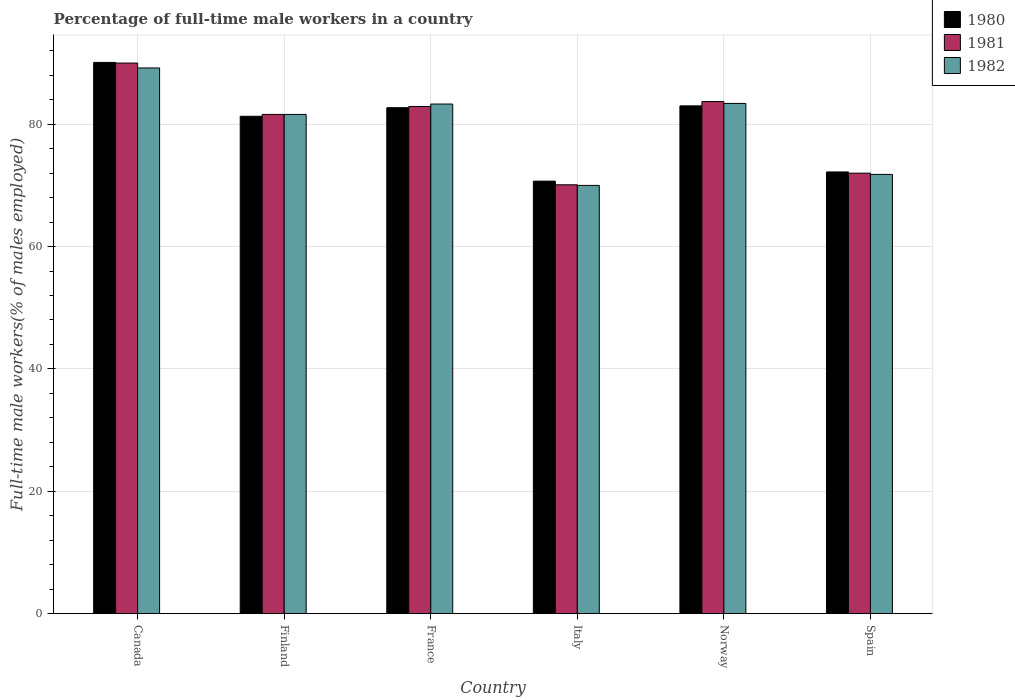How many different coloured bars are there?
Ensure brevity in your answer.  3. How many groups of bars are there?
Keep it short and to the point. 6. Are the number of bars on each tick of the X-axis equal?
Provide a succinct answer. Yes. How many bars are there on the 2nd tick from the left?
Make the answer very short. 3. How many bars are there on the 1st tick from the right?
Your response must be concise. 3. In how many cases, is the number of bars for a given country not equal to the number of legend labels?
Make the answer very short. 0. What is the percentage of full-time male workers in 1982 in Finland?
Your answer should be very brief. 81.6. Across all countries, what is the maximum percentage of full-time male workers in 1980?
Your response must be concise. 90.1. In which country was the percentage of full-time male workers in 1981 maximum?
Your answer should be very brief. Canada. In which country was the percentage of full-time male workers in 1981 minimum?
Keep it short and to the point. Italy. What is the total percentage of full-time male workers in 1982 in the graph?
Offer a terse response. 479.3. What is the difference between the percentage of full-time male workers in 1981 in France and that in Spain?
Your answer should be very brief. 10.9. What is the difference between the percentage of full-time male workers in 1981 in France and the percentage of full-time male workers in 1980 in Italy?
Your response must be concise. 12.2. What is the average percentage of full-time male workers in 1982 per country?
Make the answer very short. 79.88. What is the difference between the percentage of full-time male workers of/in 1980 and percentage of full-time male workers of/in 1981 in Canada?
Ensure brevity in your answer.  0.1. What is the ratio of the percentage of full-time male workers in 1980 in Finland to that in Italy?
Give a very brief answer. 1.15. What is the difference between the highest and the second highest percentage of full-time male workers in 1982?
Offer a very short reply. 5.9. What is the difference between the highest and the lowest percentage of full-time male workers in 1980?
Make the answer very short. 19.4. In how many countries, is the percentage of full-time male workers in 1980 greater than the average percentage of full-time male workers in 1980 taken over all countries?
Provide a short and direct response. 4. Is the sum of the percentage of full-time male workers in 1982 in Canada and Italy greater than the maximum percentage of full-time male workers in 1980 across all countries?
Ensure brevity in your answer.  Yes. What does the 3rd bar from the left in Italy represents?
Your response must be concise. 1982. Is it the case that in every country, the sum of the percentage of full-time male workers in 1981 and percentage of full-time male workers in 1980 is greater than the percentage of full-time male workers in 1982?
Ensure brevity in your answer.  Yes. How many bars are there?
Your response must be concise. 18. Are all the bars in the graph horizontal?
Your answer should be compact. No. How many countries are there in the graph?
Your answer should be very brief. 6. What is the difference between two consecutive major ticks on the Y-axis?
Provide a short and direct response. 20. Are the values on the major ticks of Y-axis written in scientific E-notation?
Provide a succinct answer. No. Where does the legend appear in the graph?
Make the answer very short. Top right. How many legend labels are there?
Ensure brevity in your answer.  3. How are the legend labels stacked?
Keep it short and to the point. Vertical. What is the title of the graph?
Keep it short and to the point. Percentage of full-time male workers in a country. What is the label or title of the Y-axis?
Give a very brief answer. Full-time male workers(% of males employed). What is the Full-time male workers(% of males employed) of 1980 in Canada?
Offer a terse response. 90.1. What is the Full-time male workers(% of males employed) in 1981 in Canada?
Offer a terse response. 90. What is the Full-time male workers(% of males employed) of 1982 in Canada?
Make the answer very short. 89.2. What is the Full-time male workers(% of males employed) in 1980 in Finland?
Give a very brief answer. 81.3. What is the Full-time male workers(% of males employed) of 1981 in Finland?
Offer a very short reply. 81.6. What is the Full-time male workers(% of males employed) of 1982 in Finland?
Your answer should be very brief. 81.6. What is the Full-time male workers(% of males employed) of 1980 in France?
Make the answer very short. 82.7. What is the Full-time male workers(% of males employed) of 1981 in France?
Your answer should be compact. 82.9. What is the Full-time male workers(% of males employed) in 1982 in France?
Your answer should be compact. 83.3. What is the Full-time male workers(% of males employed) of 1980 in Italy?
Provide a short and direct response. 70.7. What is the Full-time male workers(% of males employed) of 1981 in Italy?
Make the answer very short. 70.1. What is the Full-time male workers(% of males employed) in 1982 in Italy?
Ensure brevity in your answer.  70. What is the Full-time male workers(% of males employed) in 1981 in Norway?
Keep it short and to the point. 83.7. What is the Full-time male workers(% of males employed) in 1982 in Norway?
Keep it short and to the point. 83.4. What is the Full-time male workers(% of males employed) in 1980 in Spain?
Ensure brevity in your answer.  72.2. What is the Full-time male workers(% of males employed) of 1982 in Spain?
Your answer should be compact. 71.8. Across all countries, what is the maximum Full-time male workers(% of males employed) of 1980?
Provide a short and direct response. 90.1. Across all countries, what is the maximum Full-time male workers(% of males employed) in 1982?
Ensure brevity in your answer.  89.2. Across all countries, what is the minimum Full-time male workers(% of males employed) of 1980?
Offer a terse response. 70.7. Across all countries, what is the minimum Full-time male workers(% of males employed) of 1981?
Keep it short and to the point. 70.1. What is the total Full-time male workers(% of males employed) of 1980 in the graph?
Offer a terse response. 480. What is the total Full-time male workers(% of males employed) of 1981 in the graph?
Your answer should be very brief. 480.3. What is the total Full-time male workers(% of males employed) of 1982 in the graph?
Provide a short and direct response. 479.3. What is the difference between the Full-time male workers(% of males employed) in 1982 in Canada and that in Finland?
Keep it short and to the point. 7.6. What is the difference between the Full-time male workers(% of males employed) in 1980 in Canada and that in France?
Your response must be concise. 7.4. What is the difference between the Full-time male workers(% of males employed) in 1982 in Canada and that in France?
Keep it short and to the point. 5.9. What is the difference between the Full-time male workers(% of males employed) in 1981 in Canada and that in Italy?
Make the answer very short. 19.9. What is the difference between the Full-time male workers(% of males employed) in 1980 in Canada and that in Norway?
Keep it short and to the point. 7.1. What is the difference between the Full-time male workers(% of males employed) in 1981 in Canada and that in Spain?
Offer a very short reply. 18. What is the difference between the Full-time male workers(% of males employed) in 1981 in Finland and that in France?
Make the answer very short. -1.3. What is the difference between the Full-time male workers(% of males employed) in 1982 in Finland and that in France?
Provide a succinct answer. -1.7. What is the difference between the Full-time male workers(% of males employed) of 1980 in Finland and that in Italy?
Your answer should be very brief. 10.6. What is the difference between the Full-time male workers(% of males employed) of 1981 in Finland and that in Norway?
Keep it short and to the point. -2.1. What is the difference between the Full-time male workers(% of males employed) in 1982 in France and that in Italy?
Your answer should be compact. 13.3. What is the difference between the Full-time male workers(% of males employed) in 1980 in France and that in Norway?
Your answer should be very brief. -0.3. What is the difference between the Full-time male workers(% of males employed) of 1982 in France and that in Norway?
Provide a succinct answer. -0.1. What is the difference between the Full-time male workers(% of males employed) of 1982 in France and that in Spain?
Your answer should be very brief. 11.5. What is the difference between the Full-time male workers(% of males employed) in 1982 in Italy and that in Spain?
Offer a terse response. -1.8. What is the difference between the Full-time male workers(% of males employed) of 1981 in Norway and that in Spain?
Your answer should be very brief. 11.7. What is the difference between the Full-time male workers(% of males employed) of 1982 in Norway and that in Spain?
Provide a short and direct response. 11.6. What is the difference between the Full-time male workers(% of males employed) in 1980 in Canada and the Full-time male workers(% of males employed) in 1981 in Finland?
Offer a terse response. 8.5. What is the difference between the Full-time male workers(% of males employed) of 1980 in Canada and the Full-time male workers(% of males employed) of 1982 in Finland?
Provide a succinct answer. 8.5. What is the difference between the Full-time male workers(% of males employed) in 1980 in Canada and the Full-time male workers(% of males employed) in 1982 in Italy?
Offer a terse response. 20.1. What is the difference between the Full-time male workers(% of males employed) in 1981 in Canada and the Full-time male workers(% of males employed) in 1982 in Spain?
Your answer should be compact. 18.2. What is the difference between the Full-time male workers(% of males employed) in 1980 in Finland and the Full-time male workers(% of males employed) in 1982 in France?
Offer a terse response. -2. What is the difference between the Full-time male workers(% of males employed) in 1981 in Finland and the Full-time male workers(% of males employed) in 1982 in France?
Your answer should be very brief. -1.7. What is the difference between the Full-time male workers(% of males employed) of 1981 in Finland and the Full-time male workers(% of males employed) of 1982 in Italy?
Your answer should be compact. 11.6. What is the difference between the Full-time male workers(% of males employed) in 1980 in Finland and the Full-time male workers(% of males employed) in 1982 in Norway?
Your answer should be very brief. -2.1. What is the difference between the Full-time male workers(% of males employed) in 1980 in France and the Full-time male workers(% of males employed) in 1982 in Norway?
Your answer should be compact. -0.7. What is the difference between the Full-time male workers(% of males employed) in 1981 in France and the Full-time male workers(% of males employed) in 1982 in Norway?
Provide a short and direct response. -0.5. What is the difference between the Full-time male workers(% of males employed) of 1980 in France and the Full-time male workers(% of males employed) of 1981 in Spain?
Offer a terse response. 10.7. What is the difference between the Full-time male workers(% of males employed) of 1980 in France and the Full-time male workers(% of males employed) of 1982 in Spain?
Give a very brief answer. 10.9. What is the difference between the Full-time male workers(% of males employed) of 1980 in Italy and the Full-time male workers(% of males employed) of 1981 in Norway?
Your response must be concise. -13. What is the difference between the Full-time male workers(% of males employed) in 1981 in Italy and the Full-time male workers(% of males employed) in 1982 in Norway?
Make the answer very short. -13.3. What is the difference between the Full-time male workers(% of males employed) in 1980 in Italy and the Full-time male workers(% of males employed) in 1981 in Spain?
Your response must be concise. -1.3. What is the difference between the Full-time male workers(% of males employed) in 1981 in Norway and the Full-time male workers(% of males employed) in 1982 in Spain?
Your response must be concise. 11.9. What is the average Full-time male workers(% of males employed) in 1980 per country?
Ensure brevity in your answer.  80. What is the average Full-time male workers(% of males employed) in 1981 per country?
Provide a short and direct response. 80.05. What is the average Full-time male workers(% of males employed) in 1982 per country?
Your answer should be very brief. 79.88. What is the difference between the Full-time male workers(% of males employed) of 1980 and Full-time male workers(% of males employed) of 1981 in Canada?
Ensure brevity in your answer.  0.1. What is the difference between the Full-time male workers(% of males employed) in 1981 and Full-time male workers(% of males employed) in 1982 in Canada?
Provide a short and direct response. 0.8. What is the difference between the Full-time male workers(% of males employed) of 1980 and Full-time male workers(% of males employed) of 1981 in Finland?
Offer a very short reply. -0.3. What is the difference between the Full-time male workers(% of males employed) of 1980 and Full-time male workers(% of males employed) of 1982 in France?
Your answer should be very brief. -0.6. What is the difference between the Full-time male workers(% of males employed) of 1980 and Full-time male workers(% of males employed) of 1982 in Italy?
Provide a short and direct response. 0.7. What is the difference between the Full-time male workers(% of males employed) in 1980 and Full-time male workers(% of males employed) in 1981 in Norway?
Your response must be concise. -0.7. What is the difference between the Full-time male workers(% of males employed) of 1980 and Full-time male workers(% of males employed) of 1982 in Spain?
Ensure brevity in your answer.  0.4. What is the ratio of the Full-time male workers(% of males employed) of 1980 in Canada to that in Finland?
Your answer should be compact. 1.11. What is the ratio of the Full-time male workers(% of males employed) of 1981 in Canada to that in Finland?
Your answer should be compact. 1.1. What is the ratio of the Full-time male workers(% of males employed) of 1982 in Canada to that in Finland?
Your response must be concise. 1.09. What is the ratio of the Full-time male workers(% of males employed) of 1980 in Canada to that in France?
Provide a succinct answer. 1.09. What is the ratio of the Full-time male workers(% of males employed) of 1981 in Canada to that in France?
Offer a terse response. 1.09. What is the ratio of the Full-time male workers(% of males employed) of 1982 in Canada to that in France?
Offer a terse response. 1.07. What is the ratio of the Full-time male workers(% of males employed) of 1980 in Canada to that in Italy?
Your answer should be compact. 1.27. What is the ratio of the Full-time male workers(% of males employed) of 1981 in Canada to that in Italy?
Offer a very short reply. 1.28. What is the ratio of the Full-time male workers(% of males employed) of 1982 in Canada to that in Italy?
Give a very brief answer. 1.27. What is the ratio of the Full-time male workers(% of males employed) in 1980 in Canada to that in Norway?
Give a very brief answer. 1.09. What is the ratio of the Full-time male workers(% of males employed) in 1981 in Canada to that in Norway?
Keep it short and to the point. 1.08. What is the ratio of the Full-time male workers(% of males employed) of 1982 in Canada to that in Norway?
Offer a terse response. 1.07. What is the ratio of the Full-time male workers(% of males employed) of 1980 in Canada to that in Spain?
Your answer should be very brief. 1.25. What is the ratio of the Full-time male workers(% of males employed) of 1981 in Canada to that in Spain?
Offer a terse response. 1.25. What is the ratio of the Full-time male workers(% of males employed) in 1982 in Canada to that in Spain?
Offer a very short reply. 1.24. What is the ratio of the Full-time male workers(% of males employed) of 1980 in Finland to that in France?
Offer a terse response. 0.98. What is the ratio of the Full-time male workers(% of males employed) in 1981 in Finland to that in France?
Make the answer very short. 0.98. What is the ratio of the Full-time male workers(% of males employed) in 1982 in Finland to that in France?
Keep it short and to the point. 0.98. What is the ratio of the Full-time male workers(% of males employed) in 1980 in Finland to that in Italy?
Ensure brevity in your answer.  1.15. What is the ratio of the Full-time male workers(% of males employed) of 1981 in Finland to that in Italy?
Make the answer very short. 1.16. What is the ratio of the Full-time male workers(% of males employed) of 1982 in Finland to that in Italy?
Your answer should be compact. 1.17. What is the ratio of the Full-time male workers(% of males employed) in 1980 in Finland to that in Norway?
Provide a short and direct response. 0.98. What is the ratio of the Full-time male workers(% of males employed) in 1981 in Finland to that in Norway?
Provide a succinct answer. 0.97. What is the ratio of the Full-time male workers(% of males employed) in 1982 in Finland to that in Norway?
Provide a short and direct response. 0.98. What is the ratio of the Full-time male workers(% of males employed) of 1980 in Finland to that in Spain?
Your answer should be very brief. 1.13. What is the ratio of the Full-time male workers(% of males employed) in 1981 in Finland to that in Spain?
Provide a succinct answer. 1.13. What is the ratio of the Full-time male workers(% of males employed) of 1982 in Finland to that in Spain?
Offer a very short reply. 1.14. What is the ratio of the Full-time male workers(% of males employed) of 1980 in France to that in Italy?
Your response must be concise. 1.17. What is the ratio of the Full-time male workers(% of males employed) of 1981 in France to that in Italy?
Your answer should be compact. 1.18. What is the ratio of the Full-time male workers(% of males employed) of 1982 in France to that in Italy?
Your answer should be compact. 1.19. What is the ratio of the Full-time male workers(% of males employed) of 1982 in France to that in Norway?
Provide a short and direct response. 1. What is the ratio of the Full-time male workers(% of males employed) of 1980 in France to that in Spain?
Offer a very short reply. 1.15. What is the ratio of the Full-time male workers(% of males employed) of 1981 in France to that in Spain?
Your response must be concise. 1.15. What is the ratio of the Full-time male workers(% of males employed) in 1982 in France to that in Spain?
Your answer should be very brief. 1.16. What is the ratio of the Full-time male workers(% of males employed) of 1980 in Italy to that in Norway?
Make the answer very short. 0.85. What is the ratio of the Full-time male workers(% of males employed) in 1981 in Italy to that in Norway?
Your answer should be very brief. 0.84. What is the ratio of the Full-time male workers(% of males employed) in 1982 in Italy to that in Norway?
Your response must be concise. 0.84. What is the ratio of the Full-time male workers(% of males employed) in 1980 in Italy to that in Spain?
Your answer should be compact. 0.98. What is the ratio of the Full-time male workers(% of males employed) of 1981 in Italy to that in Spain?
Offer a very short reply. 0.97. What is the ratio of the Full-time male workers(% of males employed) in 1982 in Italy to that in Spain?
Ensure brevity in your answer.  0.97. What is the ratio of the Full-time male workers(% of males employed) in 1980 in Norway to that in Spain?
Give a very brief answer. 1.15. What is the ratio of the Full-time male workers(% of males employed) of 1981 in Norway to that in Spain?
Your answer should be very brief. 1.16. What is the ratio of the Full-time male workers(% of males employed) of 1982 in Norway to that in Spain?
Ensure brevity in your answer.  1.16. What is the difference between the highest and the second highest Full-time male workers(% of males employed) in 1980?
Your answer should be very brief. 7.1. What is the difference between the highest and the second highest Full-time male workers(% of males employed) of 1982?
Make the answer very short. 5.8. What is the difference between the highest and the lowest Full-time male workers(% of males employed) of 1980?
Offer a terse response. 19.4. 